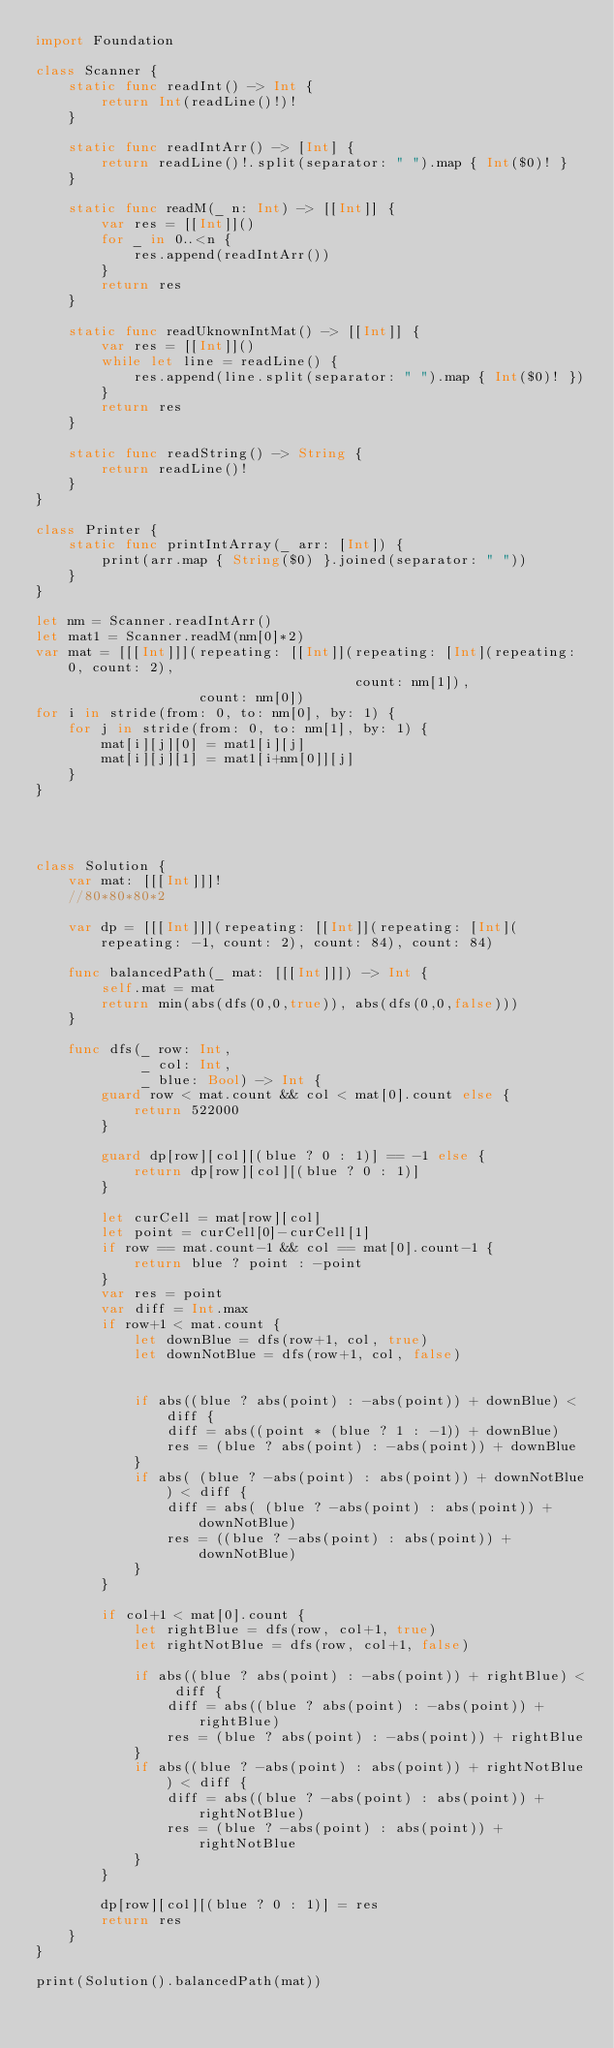Convert code to text. <code><loc_0><loc_0><loc_500><loc_500><_Swift_>import Foundation

class Scanner {
    static func readInt() -> Int {
        return Int(readLine()!)!
    }
    
    static func readIntArr() -> [Int] {
        return readLine()!.split(separator: " ").map { Int($0)! }
    }
    
    static func readM(_ n: Int) -> [[Int]] {
        var res = [[Int]]()
        for _ in 0..<n {
            res.append(readIntArr())
        }
        return res
    }
    
    static func readUknownIntMat() -> [[Int]] {
        var res = [[Int]]()
        while let line = readLine() {
            res.append(line.split(separator: " ").map { Int($0)! })
        }
        return res
    }
    
    static func readString() -> String {
        return readLine()!
    }
}

class Printer {
    static func printIntArray(_ arr: [Int]) {
        print(arr.map { String($0) }.joined(separator: " "))
    }
}

let nm = Scanner.readIntArr()
let mat1 = Scanner.readM(nm[0]*2)
var mat = [[[Int]]](repeating: [[Int]](repeating: [Int](repeating: 0, count: 2),
                                       count: nm[1]),
                    count: nm[0])
for i in stride(from: 0, to: nm[0], by: 1) {
    for j in stride(from: 0, to: nm[1], by: 1) {
        mat[i][j][0] = mat1[i][j]
        mat[i][j][1] = mat1[i+nm[0]][j]
    }
}




class Solution {
    var mat: [[[Int]]]!
    //80*80*80*2
    
    var dp = [[[Int]]](repeating: [[Int]](repeating: [Int](repeating: -1, count: 2), count: 84), count: 84)
    
    func balancedPath(_ mat: [[[Int]]]) -> Int {
        self.mat = mat
        return min(abs(dfs(0,0,true)), abs(dfs(0,0,false)))
    }
    
    func dfs(_ row: Int,
             _ col: Int,
             _ blue: Bool) -> Int {
        guard row < mat.count && col < mat[0].count else {
            return 522000
        }
        
        guard dp[row][col][(blue ? 0 : 1)] == -1 else {
            return dp[row][col][(blue ? 0 : 1)]
        }
        
        let curCell = mat[row][col]
        let point = curCell[0]-curCell[1]
        if row == mat.count-1 && col == mat[0].count-1 {
            return blue ? point : -point
        }
        var res = point
        var diff = Int.max
        if row+1 < mat.count {
            let downBlue = dfs(row+1, col, true)
            let downNotBlue = dfs(row+1, col, false)
            
            
            if abs((blue ? abs(point) : -abs(point)) + downBlue) < diff {
                diff = abs((point * (blue ? 1 : -1)) + downBlue)
                res = (blue ? abs(point) : -abs(point)) + downBlue
            }
            if abs( (blue ? -abs(point) : abs(point)) + downNotBlue) < diff {
                diff = abs( (blue ? -abs(point) : abs(point)) + downNotBlue)
                res = ((blue ? -abs(point) : abs(point)) + downNotBlue)
            }
        }
        
        if col+1 < mat[0].count {
            let rightBlue = dfs(row, col+1, true)
            let rightNotBlue = dfs(row, col+1, false)
            
            if abs((blue ? abs(point) : -abs(point)) + rightBlue) < diff {
                diff = abs((blue ? abs(point) : -abs(point)) + rightBlue)
                res = (blue ? abs(point) : -abs(point)) + rightBlue
            }
            if abs((blue ? -abs(point) : abs(point)) + rightNotBlue) < diff {
                diff = abs((blue ? -abs(point) : abs(point)) + rightNotBlue)
                res = (blue ? -abs(point) : abs(point)) + rightNotBlue
            }
        }
        
        dp[row][col][(blue ? 0 : 1)] = res
        return res
    }
}

print(Solution().balancedPath(mat))
</code> 